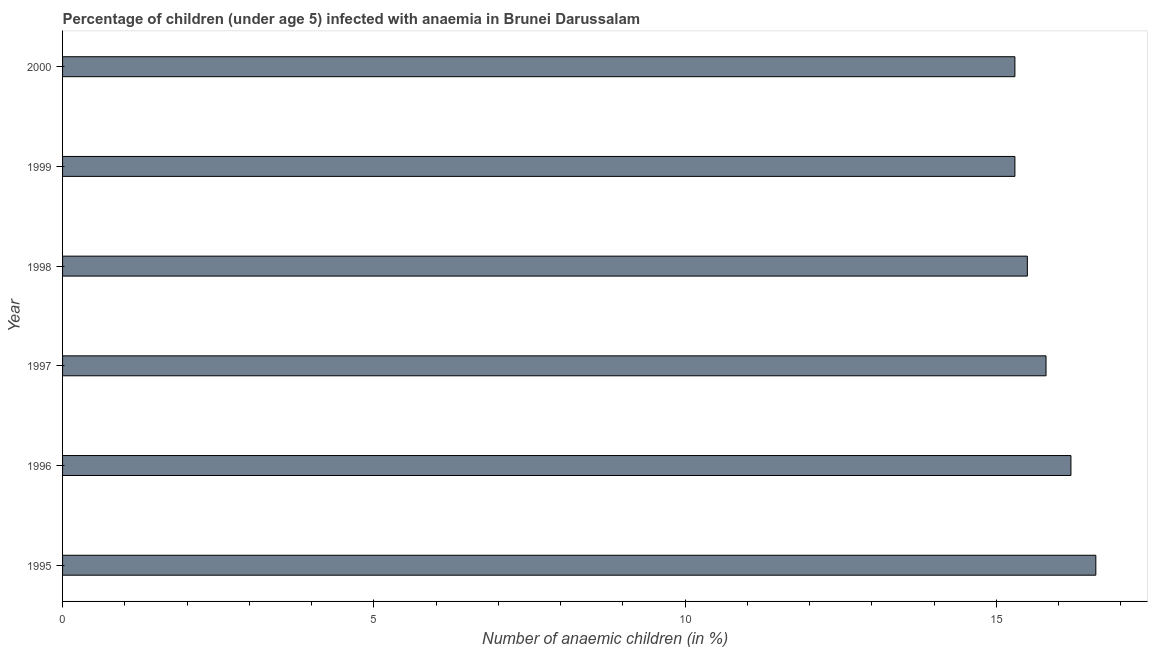What is the title of the graph?
Your answer should be compact. Percentage of children (under age 5) infected with anaemia in Brunei Darussalam. What is the label or title of the X-axis?
Provide a succinct answer. Number of anaemic children (in %). Across all years, what is the maximum number of anaemic children?
Give a very brief answer. 16.6. Across all years, what is the minimum number of anaemic children?
Your answer should be compact. 15.3. What is the sum of the number of anaemic children?
Keep it short and to the point. 94.7. What is the average number of anaemic children per year?
Offer a terse response. 15.78. What is the median number of anaemic children?
Offer a very short reply. 15.65. In how many years, is the number of anaemic children greater than 9 %?
Keep it short and to the point. 6. What is the ratio of the number of anaemic children in 1997 to that in 1999?
Make the answer very short. 1.03. Is the number of anaemic children in 1995 less than that in 2000?
Offer a very short reply. No. Is the difference between the number of anaemic children in 1998 and 2000 greater than the difference between any two years?
Offer a very short reply. No. How many bars are there?
Give a very brief answer. 6. Are all the bars in the graph horizontal?
Offer a terse response. Yes. How many years are there in the graph?
Provide a short and direct response. 6. What is the Number of anaemic children (in %) in 1995?
Give a very brief answer. 16.6. What is the Number of anaemic children (in %) of 1997?
Your answer should be compact. 15.8. What is the Number of anaemic children (in %) in 1999?
Provide a succinct answer. 15.3. What is the difference between the Number of anaemic children (in %) in 1995 and 1999?
Provide a succinct answer. 1.3. What is the difference between the Number of anaemic children (in %) in 1995 and 2000?
Keep it short and to the point. 1.3. What is the difference between the Number of anaemic children (in %) in 1996 and 1998?
Ensure brevity in your answer.  0.7. What is the difference between the Number of anaemic children (in %) in 1997 and 1998?
Provide a short and direct response. 0.3. What is the difference between the Number of anaemic children (in %) in 1997 and 1999?
Provide a succinct answer. 0.5. What is the ratio of the Number of anaemic children (in %) in 1995 to that in 1996?
Ensure brevity in your answer.  1.02. What is the ratio of the Number of anaemic children (in %) in 1995 to that in 1997?
Your response must be concise. 1.05. What is the ratio of the Number of anaemic children (in %) in 1995 to that in 1998?
Your answer should be very brief. 1.07. What is the ratio of the Number of anaemic children (in %) in 1995 to that in 1999?
Your response must be concise. 1.08. What is the ratio of the Number of anaemic children (in %) in 1995 to that in 2000?
Your response must be concise. 1.08. What is the ratio of the Number of anaemic children (in %) in 1996 to that in 1997?
Provide a short and direct response. 1.02. What is the ratio of the Number of anaemic children (in %) in 1996 to that in 1998?
Make the answer very short. 1.04. What is the ratio of the Number of anaemic children (in %) in 1996 to that in 1999?
Provide a short and direct response. 1.06. What is the ratio of the Number of anaemic children (in %) in 1996 to that in 2000?
Your response must be concise. 1.06. What is the ratio of the Number of anaemic children (in %) in 1997 to that in 1998?
Ensure brevity in your answer.  1.02. What is the ratio of the Number of anaemic children (in %) in 1997 to that in 1999?
Offer a terse response. 1.03. What is the ratio of the Number of anaemic children (in %) in 1997 to that in 2000?
Offer a terse response. 1.03. What is the ratio of the Number of anaemic children (in %) in 1998 to that in 1999?
Provide a short and direct response. 1.01. 